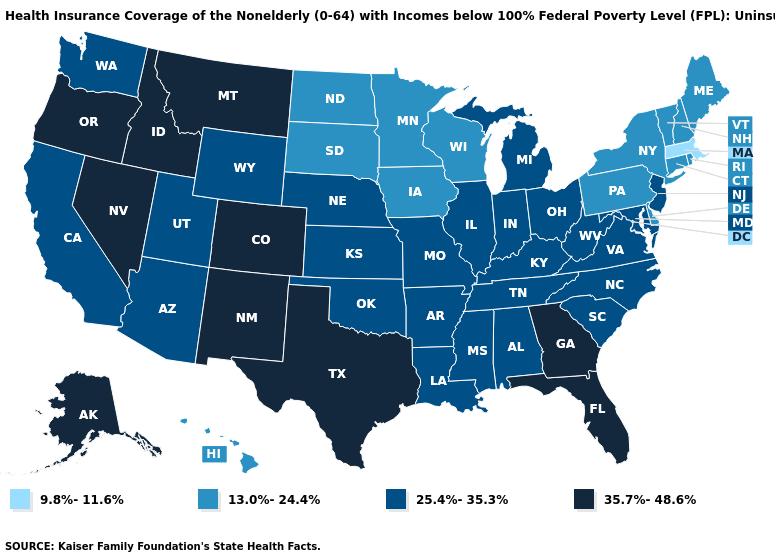Name the states that have a value in the range 35.7%-48.6%?
Keep it brief. Alaska, Colorado, Florida, Georgia, Idaho, Montana, Nevada, New Mexico, Oregon, Texas. Does New Hampshire have the lowest value in the Northeast?
Keep it brief. No. Does Kentucky have a lower value than Kansas?
Quick response, please. No. Does Florida have a higher value than Nevada?
Concise answer only. No. Does Massachusetts have the lowest value in the USA?
Short answer required. Yes. Does Utah have the same value as Alabama?
Be succinct. Yes. What is the value of New York?
Keep it brief. 13.0%-24.4%. Name the states that have a value in the range 25.4%-35.3%?
Be succinct. Alabama, Arizona, Arkansas, California, Illinois, Indiana, Kansas, Kentucky, Louisiana, Maryland, Michigan, Mississippi, Missouri, Nebraska, New Jersey, North Carolina, Ohio, Oklahoma, South Carolina, Tennessee, Utah, Virginia, Washington, West Virginia, Wyoming. Name the states that have a value in the range 9.8%-11.6%?
Be succinct. Massachusetts. What is the value of North Dakota?
Concise answer only. 13.0%-24.4%. Does Arkansas have a higher value than Virginia?
Be succinct. No. Does the map have missing data?
Answer briefly. No. What is the value of Maryland?
Short answer required. 25.4%-35.3%. Does Georgia have the same value as Tennessee?
Be succinct. No. 